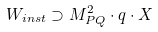Convert formula to latex. <formula><loc_0><loc_0><loc_500><loc_500>W _ { i n s t } \supset M _ { P Q } ^ { 2 } \cdot q \cdot X</formula> 